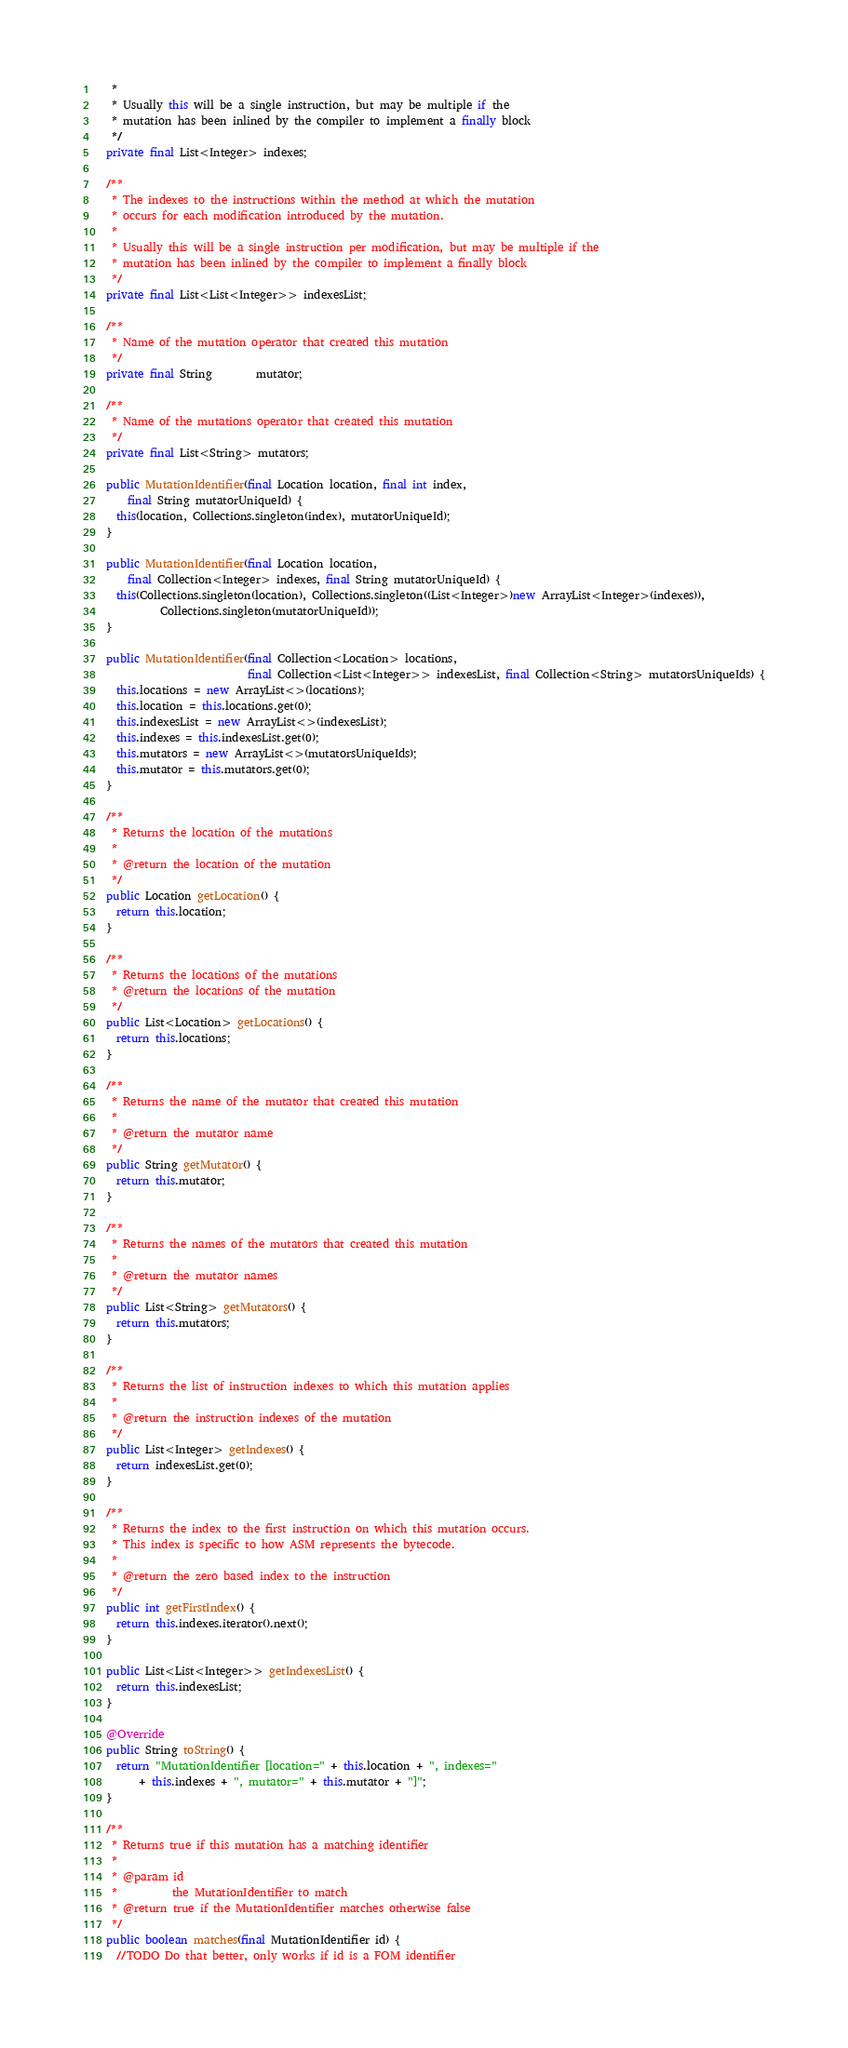<code> <loc_0><loc_0><loc_500><loc_500><_Java_>   *
   * Usually this will be a single instruction, but may be multiple if the
   * mutation has been inlined by the compiler to implement a finally block
   */
  private final List<Integer> indexes;

  /**
   * The indexes to the instructions within the method at which the mutation
   * occurs for each modification introduced by the mutation.
   *
   * Usually this will be a single instruction per modification, but may be multiple if the
   * mutation has been inlined by the compiler to implement a finally block
   */
  private final List<List<Integer>> indexesList;

  /**
   * Name of the mutation operator that created this mutation
   */
  private final String        mutator;

  /**
   * Name of the mutations operator that created this mutation
   */
  private final List<String> mutators;

  public MutationIdentifier(final Location location, final int index,
      final String mutatorUniqueId) {
    this(location, Collections.singleton(index), mutatorUniqueId);
  }

  public MutationIdentifier(final Location location,
      final Collection<Integer> indexes, final String mutatorUniqueId) {
    this(Collections.singleton(location), Collections.singleton((List<Integer>)new ArrayList<Integer>(indexes)),
            Collections.singleton(mutatorUniqueId));
  }

  public MutationIdentifier(final Collection<Location> locations,
                            final Collection<List<Integer>> indexesList, final Collection<String> mutatorsUniqueIds) {
    this.locations = new ArrayList<>(locations);
    this.location = this.locations.get(0);
    this.indexesList = new ArrayList<>(indexesList);
    this.indexes = this.indexesList.get(0);
    this.mutators = new ArrayList<>(mutatorsUniqueIds);
    this.mutator = this.mutators.get(0);
  }

  /**
   * Returns the location of the mutations
   *
   * @return the location of the mutation
   */
  public Location getLocation() {
    return this.location;
  }

  /**
   * Returns the locations of the mutations
   * @return the locations of the mutation
   */
  public List<Location> getLocations() {
    return this.locations;
  }

  /**
   * Returns the name of the mutator that created this mutation
   *
   * @return the mutator name
   */
  public String getMutator() {
    return this.mutator;
  }

  /**
   * Returns the names of the mutators that created this mutation
   *
   * @return the mutator names
   */
  public List<String> getMutators() {
    return this.mutators;
  }

  /**
   * Returns the list of instruction indexes to which this mutation applies
   *
   * @return the instruction indexes of the mutation
   */
  public List<Integer> getIndexes() {
    return indexesList.get(0);
  }

  /**
   * Returns the index to the first instruction on which this mutation occurs.
   * This index is specific to how ASM represents the bytecode.
   *
   * @return the zero based index to the instruction
   */
  public int getFirstIndex() {
    return this.indexes.iterator().next();
  }

  public List<List<Integer>> getIndexesList() {
    return this.indexesList;
  }

  @Override
  public String toString() {
    return "MutationIdentifier [location=" + this.location + ", indexes="
        + this.indexes + ", mutator=" + this.mutator + "]";
  }

  /**
   * Returns true if this mutation has a matching identifier
   *
   * @param id
   *          the MutationIdentifier to match
   * @return true if the MutationIdentifier matches otherwise false
   */
  public boolean matches(final MutationIdentifier id) {
    //TODO Do that better, only works if id is a FOM identifier</code> 